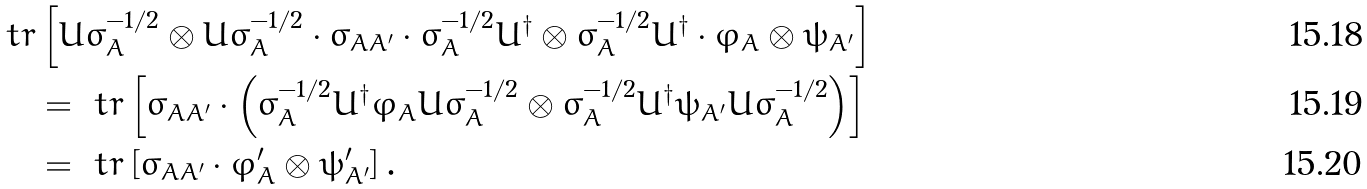Convert formula to latex. <formula><loc_0><loc_0><loc_500><loc_500>\ t r & \left [ U \sigma _ { A } ^ { - 1 / 2 } \otimes \bar { U } \bar { \sigma } _ { A } ^ { - 1 / 2 } \cdot \sigma _ { A A ^ { \prime } } \cdot \sigma _ { A } ^ { - 1 / 2 } U ^ { \dagger } \otimes \bar { \sigma } _ { A } ^ { - 1 / 2 } \bar { U } ^ { \dagger } \cdot \varphi _ { A } \otimes \psi _ { A ^ { \prime } } \right ] \\ & = \ t r \left [ \sigma _ { A A ^ { \prime } } \cdot \left ( \sigma _ { A } ^ { - 1 / 2 } U ^ { \dagger } \varphi _ { A } U \sigma _ { A } ^ { - 1 / 2 } \otimes \bar { \sigma } _ { A } ^ { - 1 / 2 } \bar { U } ^ { \dagger } \psi _ { A ^ { \prime } } \bar { U } \bar { \sigma } _ { A } ^ { - 1 / 2 } \right ) \right ] \\ & = \ t r \left [ \sigma _ { A A ^ { \prime } } \cdot \varphi ^ { \prime } _ { A } \otimes \psi ^ { \prime } _ { A ^ { \prime } } \right ] .</formula> 